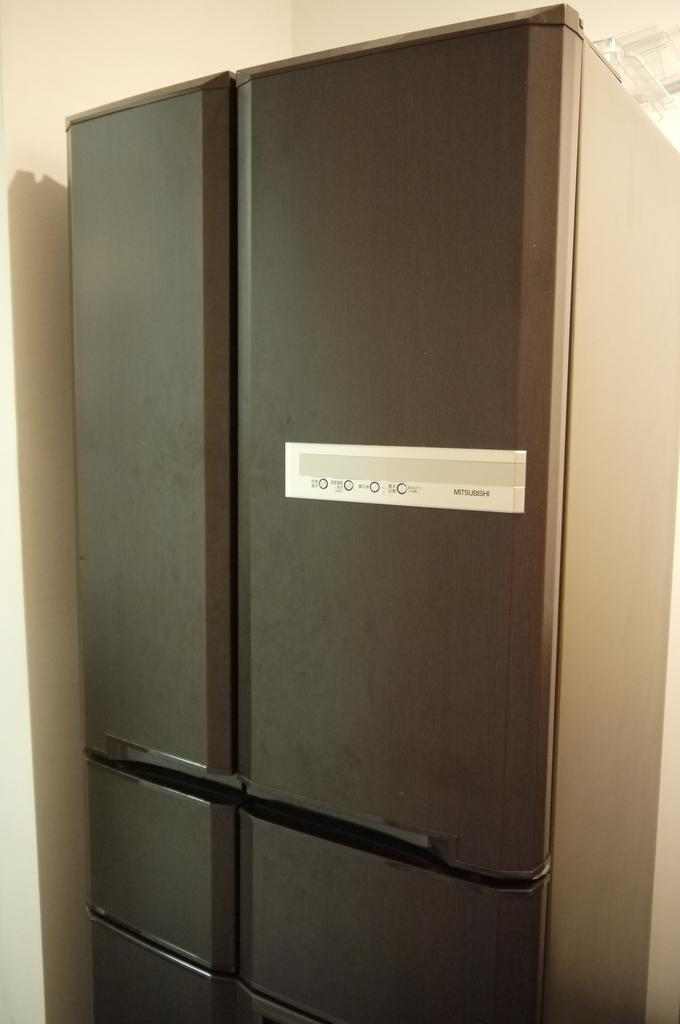<image>
Present a compact description of the photo's key features. A large metalic colored fridge made by Mitsubishi 